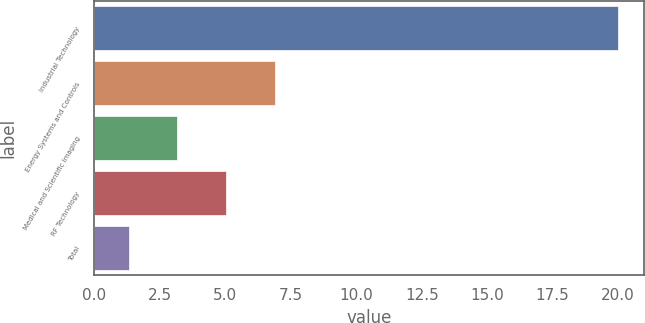<chart> <loc_0><loc_0><loc_500><loc_500><bar_chart><fcel>Industrial Technology<fcel>Energy Systems and Controls<fcel>Medical and Scientific Imaging<fcel>RF Technology<fcel>Total<nl><fcel>20<fcel>6.91<fcel>3.17<fcel>5.04<fcel>1.3<nl></chart> 